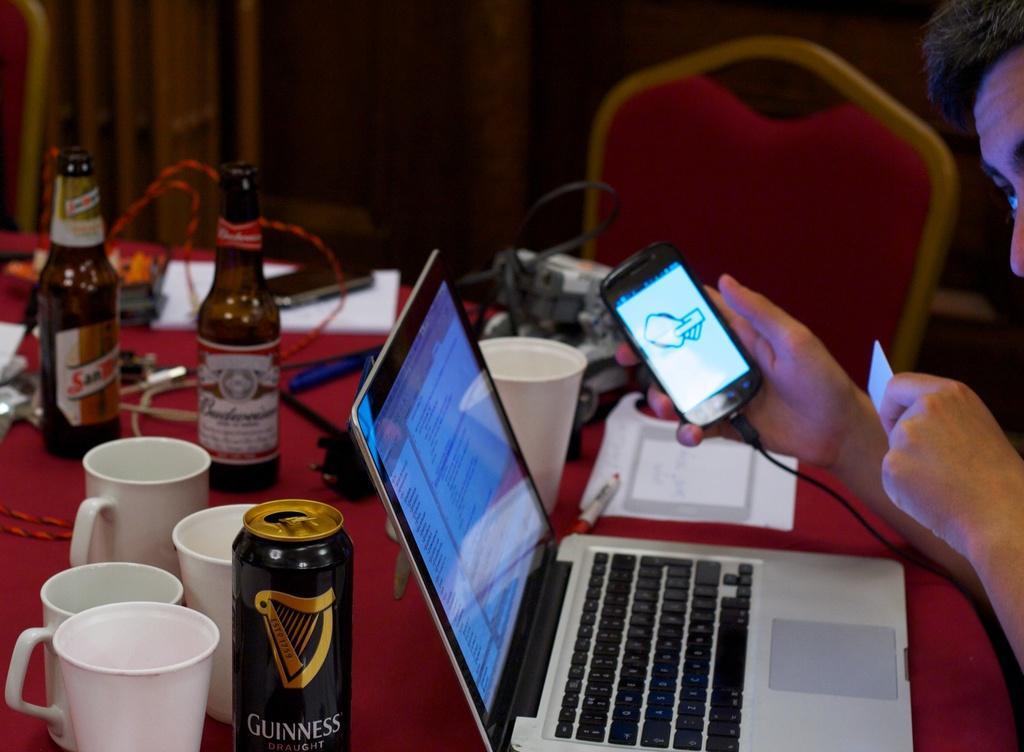Describe this image in one or two sentences. in this image there is one person is at right side of this image is holding a mobile. There is one laptop at bottom of this image which is in white color. There are some white color tea cups at left side of this image and there are some bottles are at left side of this image. there is one table at bottom of this image. All these bottles and cups are kept on it, and there is a curtain in the background and there is one chair at right side of this image. 